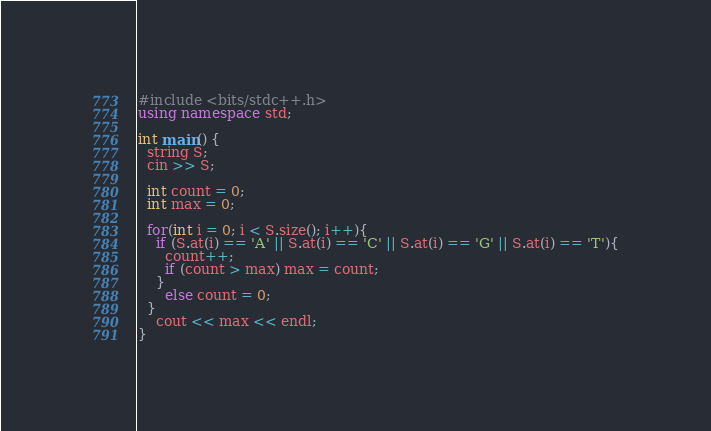<code> <loc_0><loc_0><loc_500><loc_500><_C++_>#include <bits/stdc++.h>
using namespace std;

int main() {
  string S;
  cin >> S;
  
  int count = 0;
  int max = 0;
  
  for(int i = 0; i < S.size(); i++){
    if (S.at(i) == 'A' || S.at(i) == 'C' || S.at(i) == 'G' || S.at(i) == 'T'){
      count++;
      if (count > max) max = count;
    }
      else count = 0;
  }
    cout << max << endl;
}</code> 